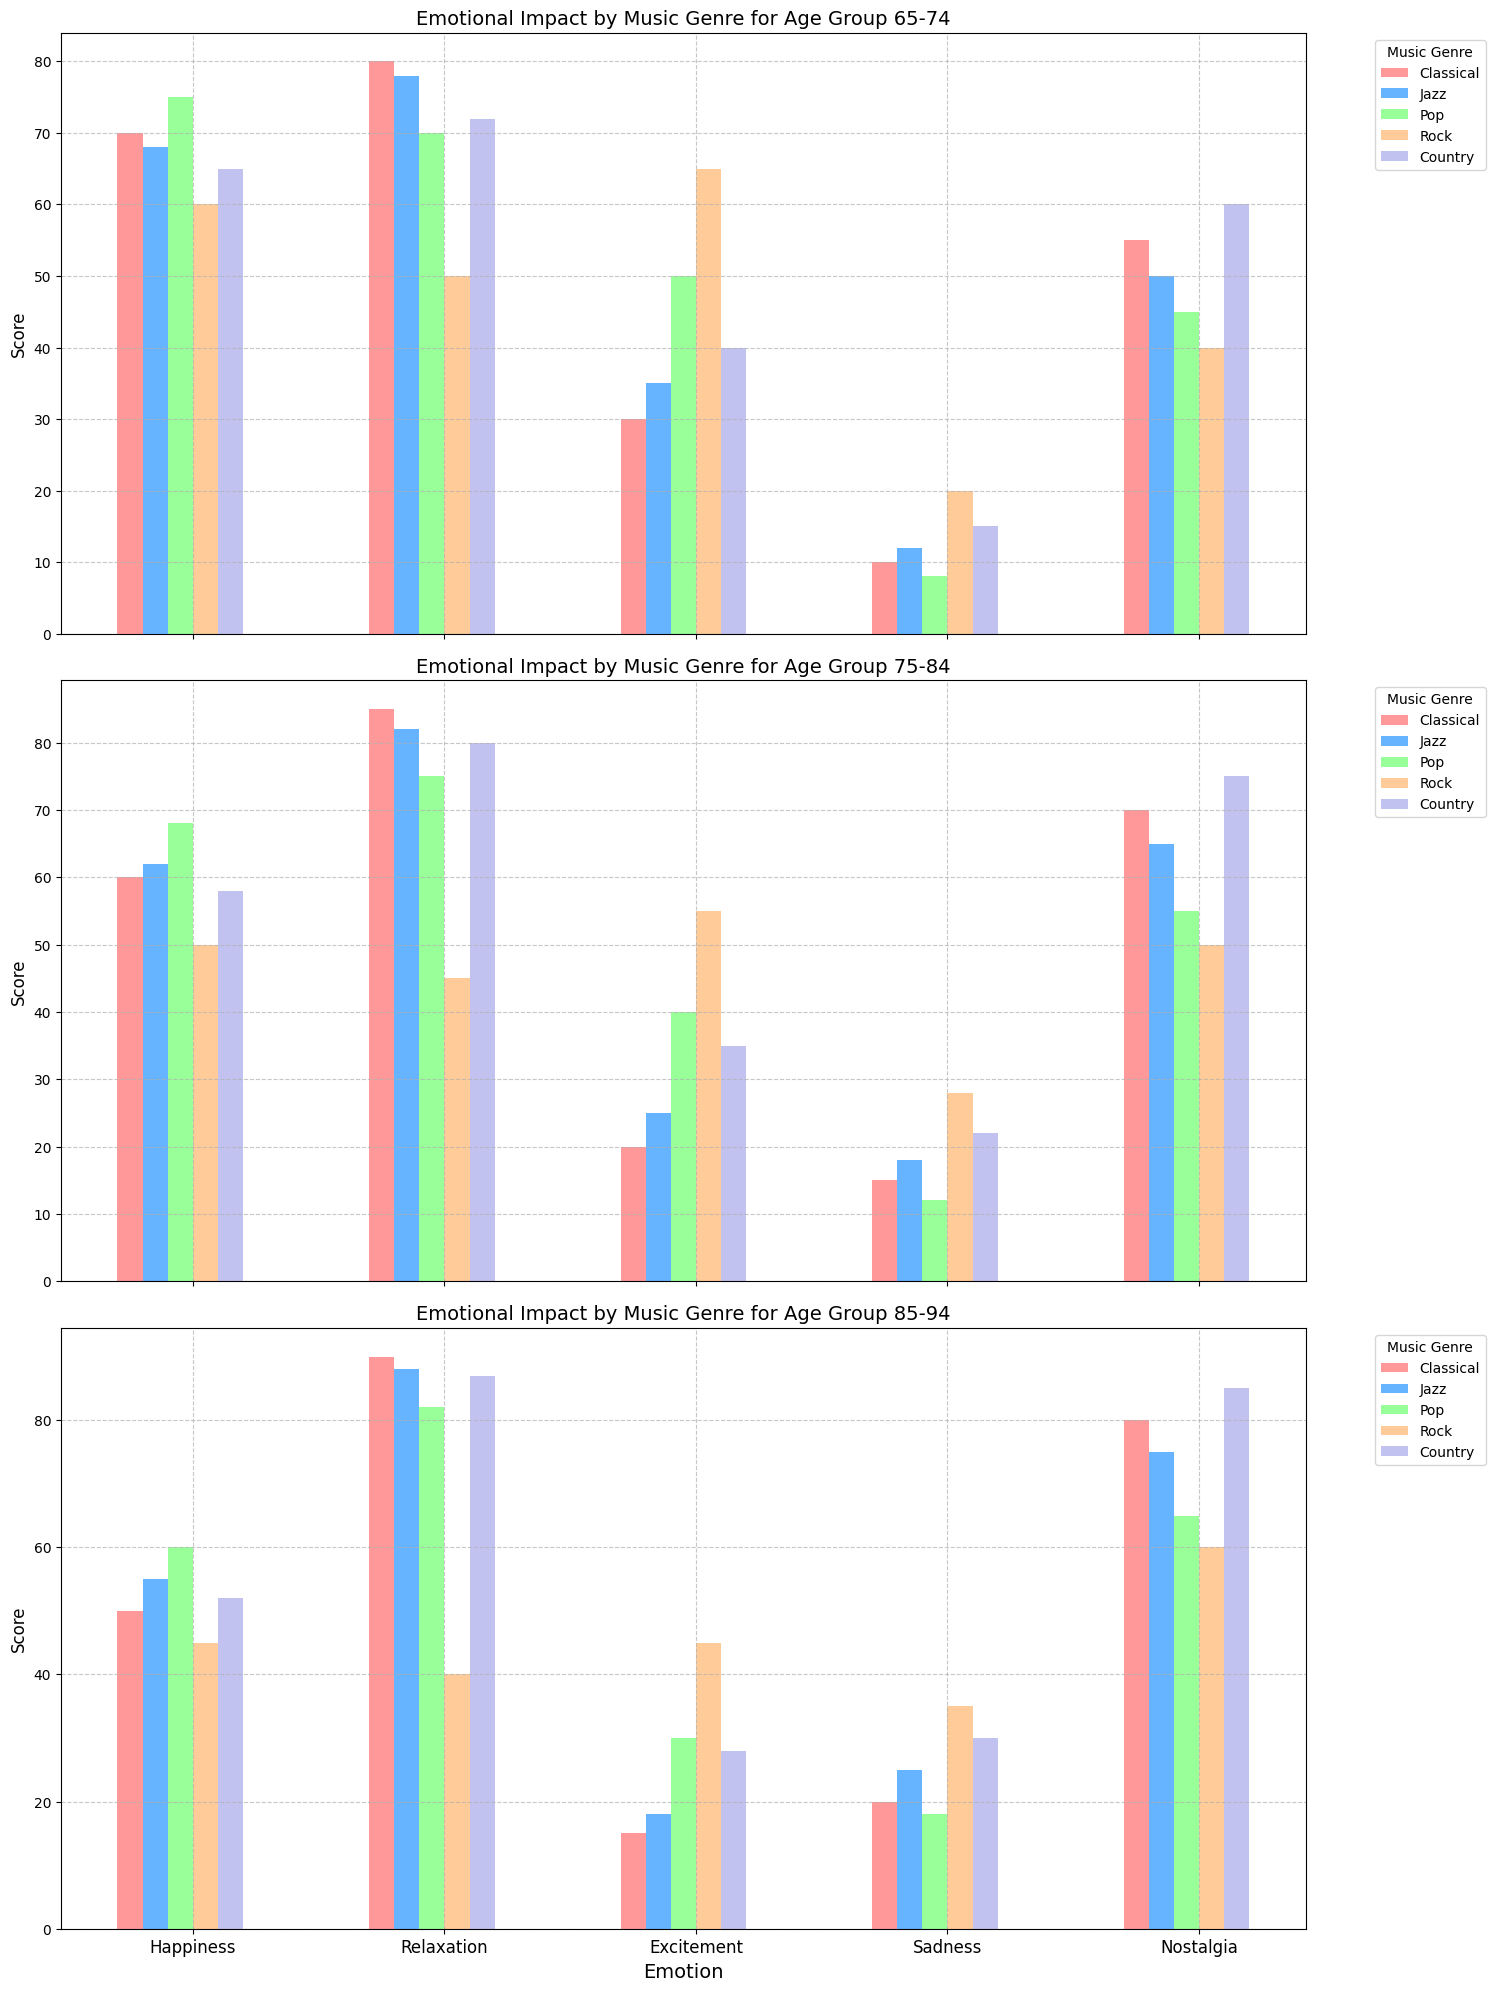Which music genre makes the 75-84 age group feel the happiest? Look at the "Happiness" bars for the 75-84 age group. The bar for "Pop" has the highest height in this age group.
Answer: Pop Which emotion does the 85-94 age group feel the least when listening to Rock music? Check the "Rock" genre bars for the 85-94 age group. The "Excitement" bar is the shortest.
Answer: Excitement Among the emotions, which one seems to show a generally increasing trend with age for the Rock genre? Look at the bars for "Rock" genre across the age groups for each emotion. The "Sadness" bars increase from 65-74 to 85-94.
Answer: Sadness How does the relaxation level induced by Jazz compare between the 65-74 and 85-94 age groups? Check the "Relaxation" bars for "Jazz" in both age groups. The bar for 85-94 is higher than the bar for 65-74.
Answer: Higher in the 85-94 group Which music genre causes the most nostalgia for the 85-94 age group? Look at the "Nostalgia" bars for the 85-94 age group. The "Country" bar is the tallest.
Answer: Country Among the age groups, which one feels the most relaxed when listening to Classical music? Compare the "Relaxation" bars for "Classical" across all age groups. The bar for 85-94 is the highest.
Answer: 85-94 What's the difference in excitement levels for Rock music between the 65-74 and 75-84 age groups? Subtract the "Excitement" value for Rock in the 75-84 age group from the "Excitement" value in the 65-74 age group: 65 - 55 = 10
Answer: 10 Which music genre appears to evoke pretty similar levels of happiness and relaxation in the 65-74 age group? Check both "Happiness" and "Relaxation" bars for each genre in the 65-74 age group. "Classical" and "Jazz" show close heights in both emotions.
Answer: Classical, Jazz What's the average excitement level for Pop music across all age groups? Add the "Excitement" values for Pop across all age groups and divide by 3: (50 + 40 + 30)/3 = 40
Answer: 40 